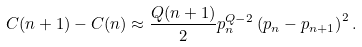<formula> <loc_0><loc_0><loc_500><loc_500>C ( n + 1 ) - C ( n ) \approx \frac { Q ( n + 1 ) } { 2 } p _ { n } ^ { Q - 2 } \left ( p _ { n } - p _ { n + 1 } \right ) ^ { 2 } .</formula> 